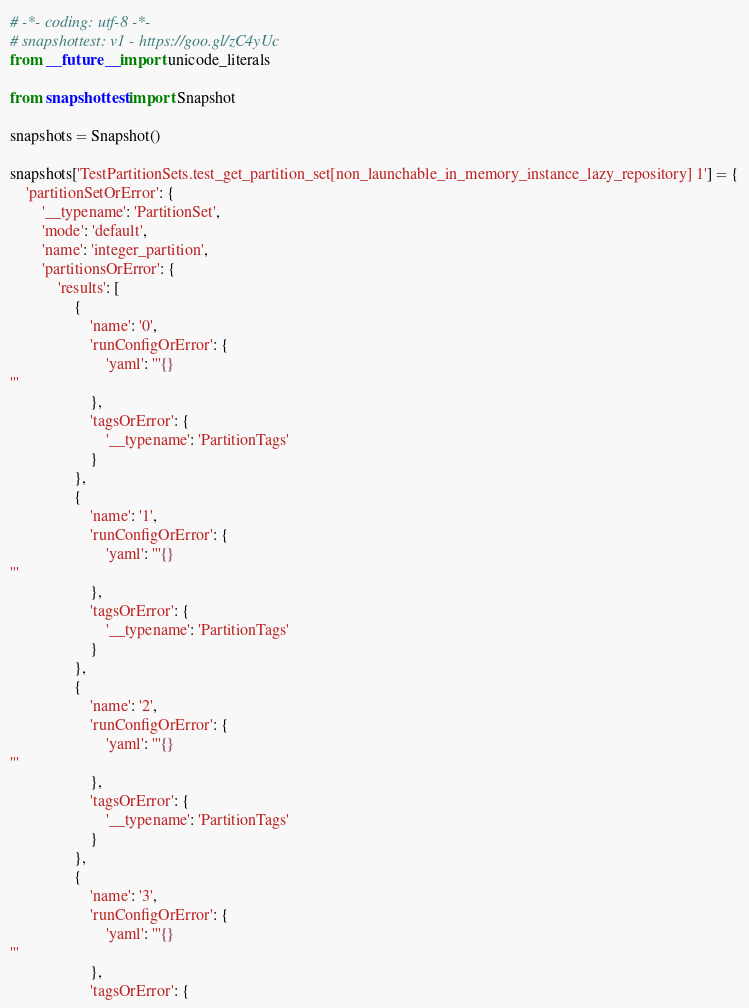Convert code to text. <code><loc_0><loc_0><loc_500><loc_500><_Python_># -*- coding: utf-8 -*-
# snapshottest: v1 - https://goo.gl/zC4yUc
from __future__ import unicode_literals

from snapshottest import Snapshot

snapshots = Snapshot()

snapshots['TestPartitionSets.test_get_partition_set[non_launchable_in_memory_instance_lazy_repository] 1'] = {
    'partitionSetOrError': {
        '__typename': 'PartitionSet',
        'mode': 'default',
        'name': 'integer_partition',
        'partitionsOrError': {
            'results': [
                {
                    'name': '0',
                    'runConfigOrError': {
                        'yaml': '''{}
'''
                    },
                    'tagsOrError': {
                        '__typename': 'PartitionTags'
                    }
                },
                {
                    'name': '1',
                    'runConfigOrError': {
                        'yaml': '''{}
'''
                    },
                    'tagsOrError': {
                        '__typename': 'PartitionTags'
                    }
                },
                {
                    'name': '2',
                    'runConfigOrError': {
                        'yaml': '''{}
'''
                    },
                    'tagsOrError': {
                        '__typename': 'PartitionTags'
                    }
                },
                {
                    'name': '3',
                    'runConfigOrError': {
                        'yaml': '''{}
'''
                    },
                    'tagsOrError': {</code> 